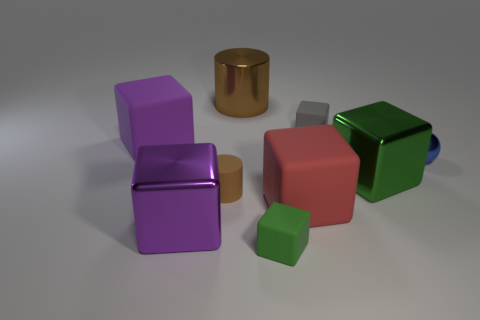What is the material of the small object that is the same color as the large cylinder?
Provide a succinct answer. Rubber. Is the material of the big purple block in front of the tiny brown matte cylinder the same as the small gray cube?
Keep it short and to the point. No. Are there the same number of big purple matte things in front of the gray matte thing and tiny cylinders that are in front of the sphere?
Give a very brief answer. Yes. What shape is the metal thing that is both to the right of the tiny green thing and in front of the metallic ball?
Provide a short and direct response. Cube. There is a purple matte cube; what number of big purple objects are on the right side of it?
Keep it short and to the point. 1. How many other objects are the same shape as the blue metal thing?
Your response must be concise. 0. Are there fewer tiny gray cubes than small purple rubber things?
Offer a terse response. No. There is a shiny object that is on the left side of the blue sphere and right of the large red thing; what size is it?
Offer a terse response. Large. There is a green object left of the tiny matte block behind the brown cylinder in front of the green metal cube; what size is it?
Ensure brevity in your answer.  Small. What is the size of the blue metal sphere?
Keep it short and to the point. Small. 